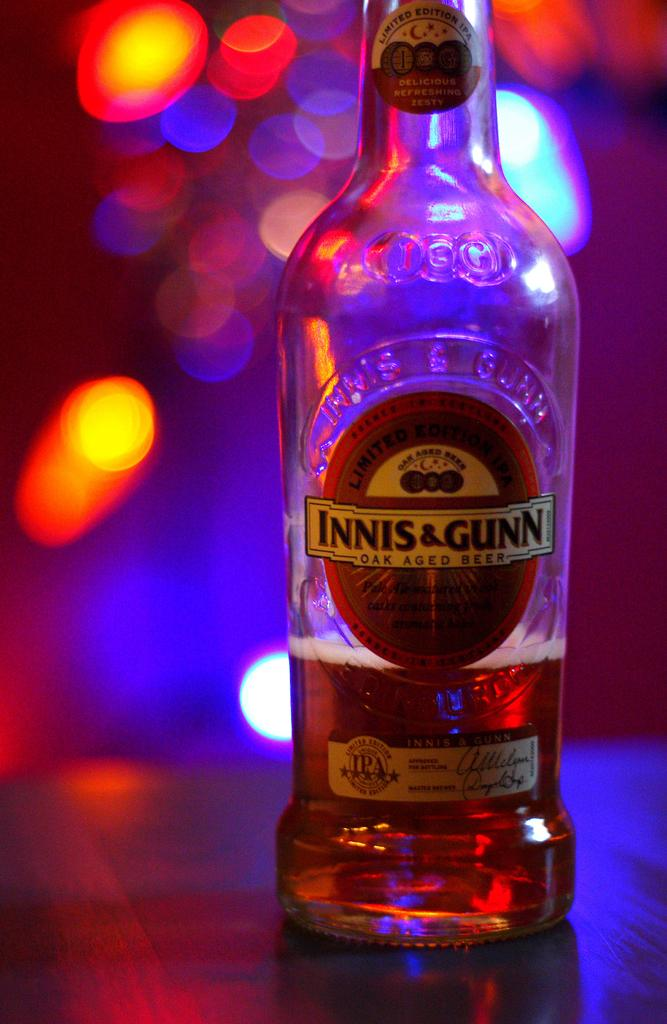Provide a one-sentence caption for the provided image. A bottle of beer has an INNIS & GUNN label on it. 